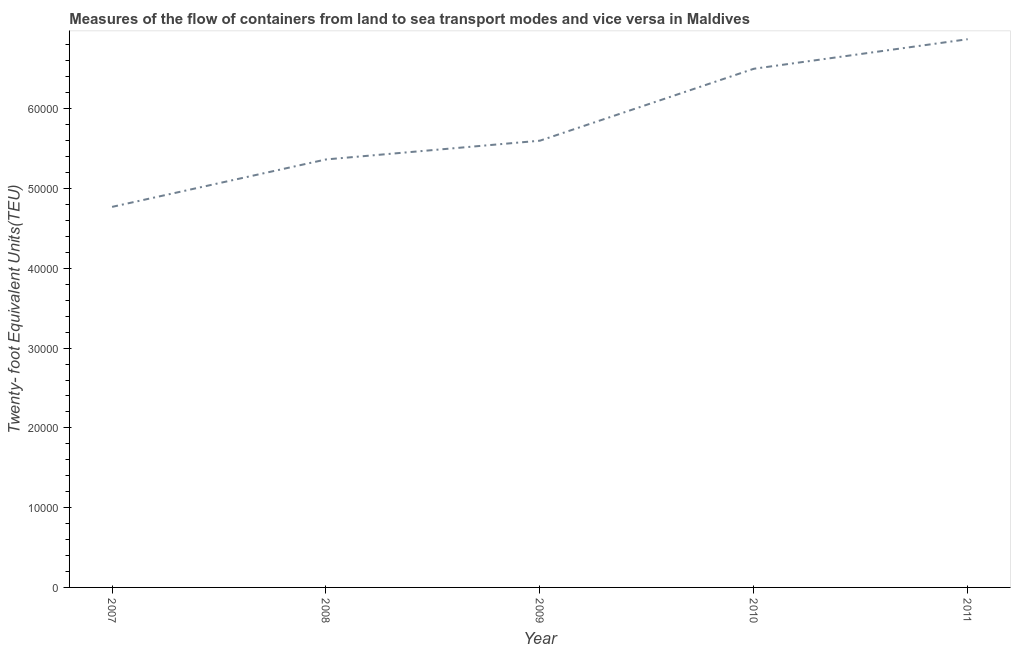What is the container port traffic in 2011?
Your response must be concise. 6.87e+04. Across all years, what is the maximum container port traffic?
Ensure brevity in your answer.  6.87e+04. Across all years, what is the minimum container port traffic?
Make the answer very short. 4.77e+04. In which year was the container port traffic maximum?
Offer a terse response. 2011. In which year was the container port traffic minimum?
Offer a very short reply. 2007. What is the sum of the container port traffic?
Keep it short and to the point. 2.91e+05. What is the difference between the container port traffic in 2008 and 2011?
Your response must be concise. -1.51e+04. What is the average container port traffic per year?
Provide a short and direct response. 5.82e+04. What is the median container port traffic?
Make the answer very short. 5.60e+04. In how many years, is the container port traffic greater than 22000 TEU?
Your answer should be very brief. 5. Do a majority of the years between 2010 and 2008 (inclusive) have container port traffic greater than 40000 TEU?
Give a very brief answer. No. What is the ratio of the container port traffic in 2007 to that in 2010?
Ensure brevity in your answer.  0.73. What is the difference between the highest and the second highest container port traffic?
Offer a terse response. 3705.91. Is the sum of the container port traffic in 2007 and 2011 greater than the maximum container port traffic across all years?
Your response must be concise. Yes. What is the difference between the highest and the lowest container port traffic?
Make the answer very short. 2.10e+04. In how many years, is the container port traffic greater than the average container port traffic taken over all years?
Your response must be concise. 2. Does the container port traffic monotonically increase over the years?
Give a very brief answer. Yes. What is the difference between two consecutive major ticks on the Y-axis?
Ensure brevity in your answer.  10000. Does the graph contain any zero values?
Ensure brevity in your answer.  No. What is the title of the graph?
Your answer should be very brief. Measures of the flow of containers from land to sea transport modes and vice versa in Maldives. What is the label or title of the Y-axis?
Your answer should be very brief. Twenty- foot Equivalent Units(TEU). What is the Twenty- foot Equivalent Units(TEU) of 2007?
Offer a very short reply. 4.77e+04. What is the Twenty- foot Equivalent Units(TEU) in 2008?
Keep it short and to the point. 5.36e+04. What is the Twenty- foot Equivalent Units(TEU) of 2009?
Provide a succinct answer. 5.60e+04. What is the Twenty- foot Equivalent Units(TEU) of 2010?
Ensure brevity in your answer.  6.50e+04. What is the Twenty- foot Equivalent Units(TEU) of 2011?
Keep it short and to the point. 6.87e+04. What is the difference between the Twenty- foot Equivalent Units(TEU) in 2007 and 2008?
Offer a very short reply. -5947. What is the difference between the Twenty- foot Equivalent Units(TEU) in 2007 and 2009?
Offer a very short reply. -8297. What is the difference between the Twenty- foot Equivalent Units(TEU) in 2007 and 2010?
Make the answer very short. -1.73e+04. What is the difference between the Twenty- foot Equivalent Units(TEU) in 2007 and 2011?
Your response must be concise. -2.10e+04. What is the difference between the Twenty- foot Equivalent Units(TEU) in 2008 and 2009?
Provide a short and direct response. -2350. What is the difference between the Twenty- foot Equivalent Units(TEU) in 2008 and 2010?
Give a very brief answer. -1.14e+04. What is the difference between the Twenty- foot Equivalent Units(TEU) in 2008 and 2011?
Offer a very short reply. -1.51e+04. What is the difference between the Twenty- foot Equivalent Units(TEU) in 2009 and 2010?
Your answer should be compact. -9016. What is the difference between the Twenty- foot Equivalent Units(TEU) in 2009 and 2011?
Offer a terse response. -1.27e+04. What is the difference between the Twenty- foot Equivalent Units(TEU) in 2010 and 2011?
Your response must be concise. -3705.91. What is the ratio of the Twenty- foot Equivalent Units(TEU) in 2007 to that in 2008?
Keep it short and to the point. 0.89. What is the ratio of the Twenty- foot Equivalent Units(TEU) in 2007 to that in 2009?
Provide a succinct answer. 0.85. What is the ratio of the Twenty- foot Equivalent Units(TEU) in 2007 to that in 2010?
Make the answer very short. 0.73. What is the ratio of the Twenty- foot Equivalent Units(TEU) in 2007 to that in 2011?
Offer a terse response. 0.69. What is the ratio of the Twenty- foot Equivalent Units(TEU) in 2008 to that in 2009?
Make the answer very short. 0.96. What is the ratio of the Twenty- foot Equivalent Units(TEU) in 2008 to that in 2010?
Ensure brevity in your answer.  0.82. What is the ratio of the Twenty- foot Equivalent Units(TEU) in 2008 to that in 2011?
Offer a very short reply. 0.78. What is the ratio of the Twenty- foot Equivalent Units(TEU) in 2009 to that in 2010?
Make the answer very short. 0.86. What is the ratio of the Twenty- foot Equivalent Units(TEU) in 2009 to that in 2011?
Your answer should be very brief. 0.81. What is the ratio of the Twenty- foot Equivalent Units(TEU) in 2010 to that in 2011?
Give a very brief answer. 0.95. 